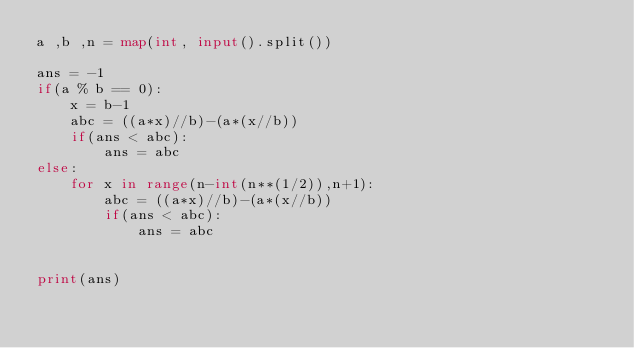<code> <loc_0><loc_0><loc_500><loc_500><_Python_>a ,b ,n = map(int, input().split())

ans = -1
if(a % b == 0):
    x = b-1
    abc = ((a*x)//b)-(a*(x//b))
    if(ans < abc):
        ans = abc
else:
    for x in range(n-int(n**(1/2)),n+1):
        abc = ((a*x)//b)-(a*(x//b))
        if(ans < abc):
            ans = abc


print(ans)</code> 